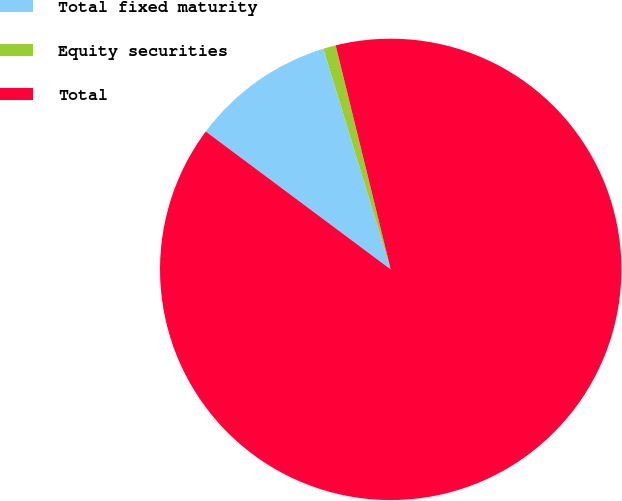Convert chart to OTSL. <chart><loc_0><loc_0><loc_500><loc_500><pie_chart><fcel>Total fixed maturity<fcel>Equity securities<fcel>Total<nl><fcel>10.09%<fcel>0.88%<fcel>89.03%<nl></chart> 